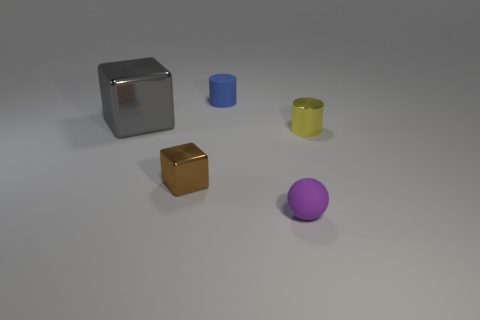Add 1 small blue matte things. How many objects exist? 6 Subtract all cubes. How many objects are left? 3 Subtract 1 blocks. How many blocks are left? 1 Subtract all blue blocks. How many yellow cylinders are left? 1 Subtract 0 cyan blocks. How many objects are left? 5 Subtract all blue spheres. Subtract all brown cylinders. How many spheres are left? 1 Subtract all tiny gray objects. Subtract all small brown blocks. How many objects are left? 4 Add 3 tiny yellow cylinders. How many tiny yellow cylinders are left? 4 Add 2 brown metal blocks. How many brown metal blocks exist? 3 